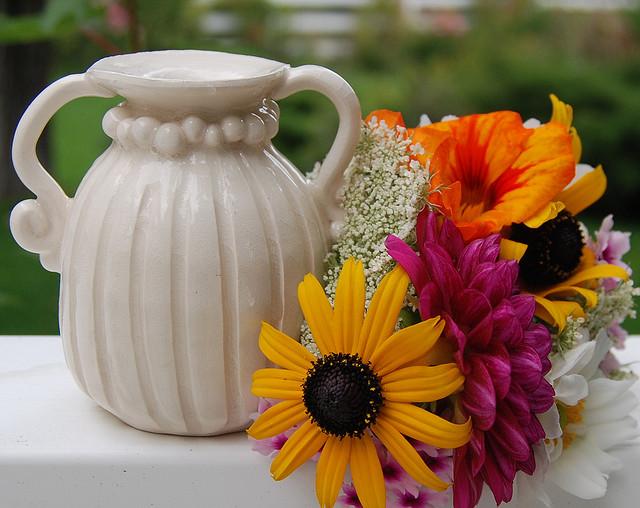What is in the vase?
Give a very brief answer. Nothing. How many pink flowers are shown?
Keep it brief. 1. Will the flowers fit in the vase?
Keep it brief. Yes. Is the vase on a pink table?
Keep it brief. No. Is the flower in a vase?
Give a very brief answer. No. What is on the vase?
Quick response, please. Flowers. What are the flowers decorating?
Be succinct. Table. Is there tea in the pot?
Give a very brief answer. No. What color are the flowers?
Be succinct. Yellow purple orange. 